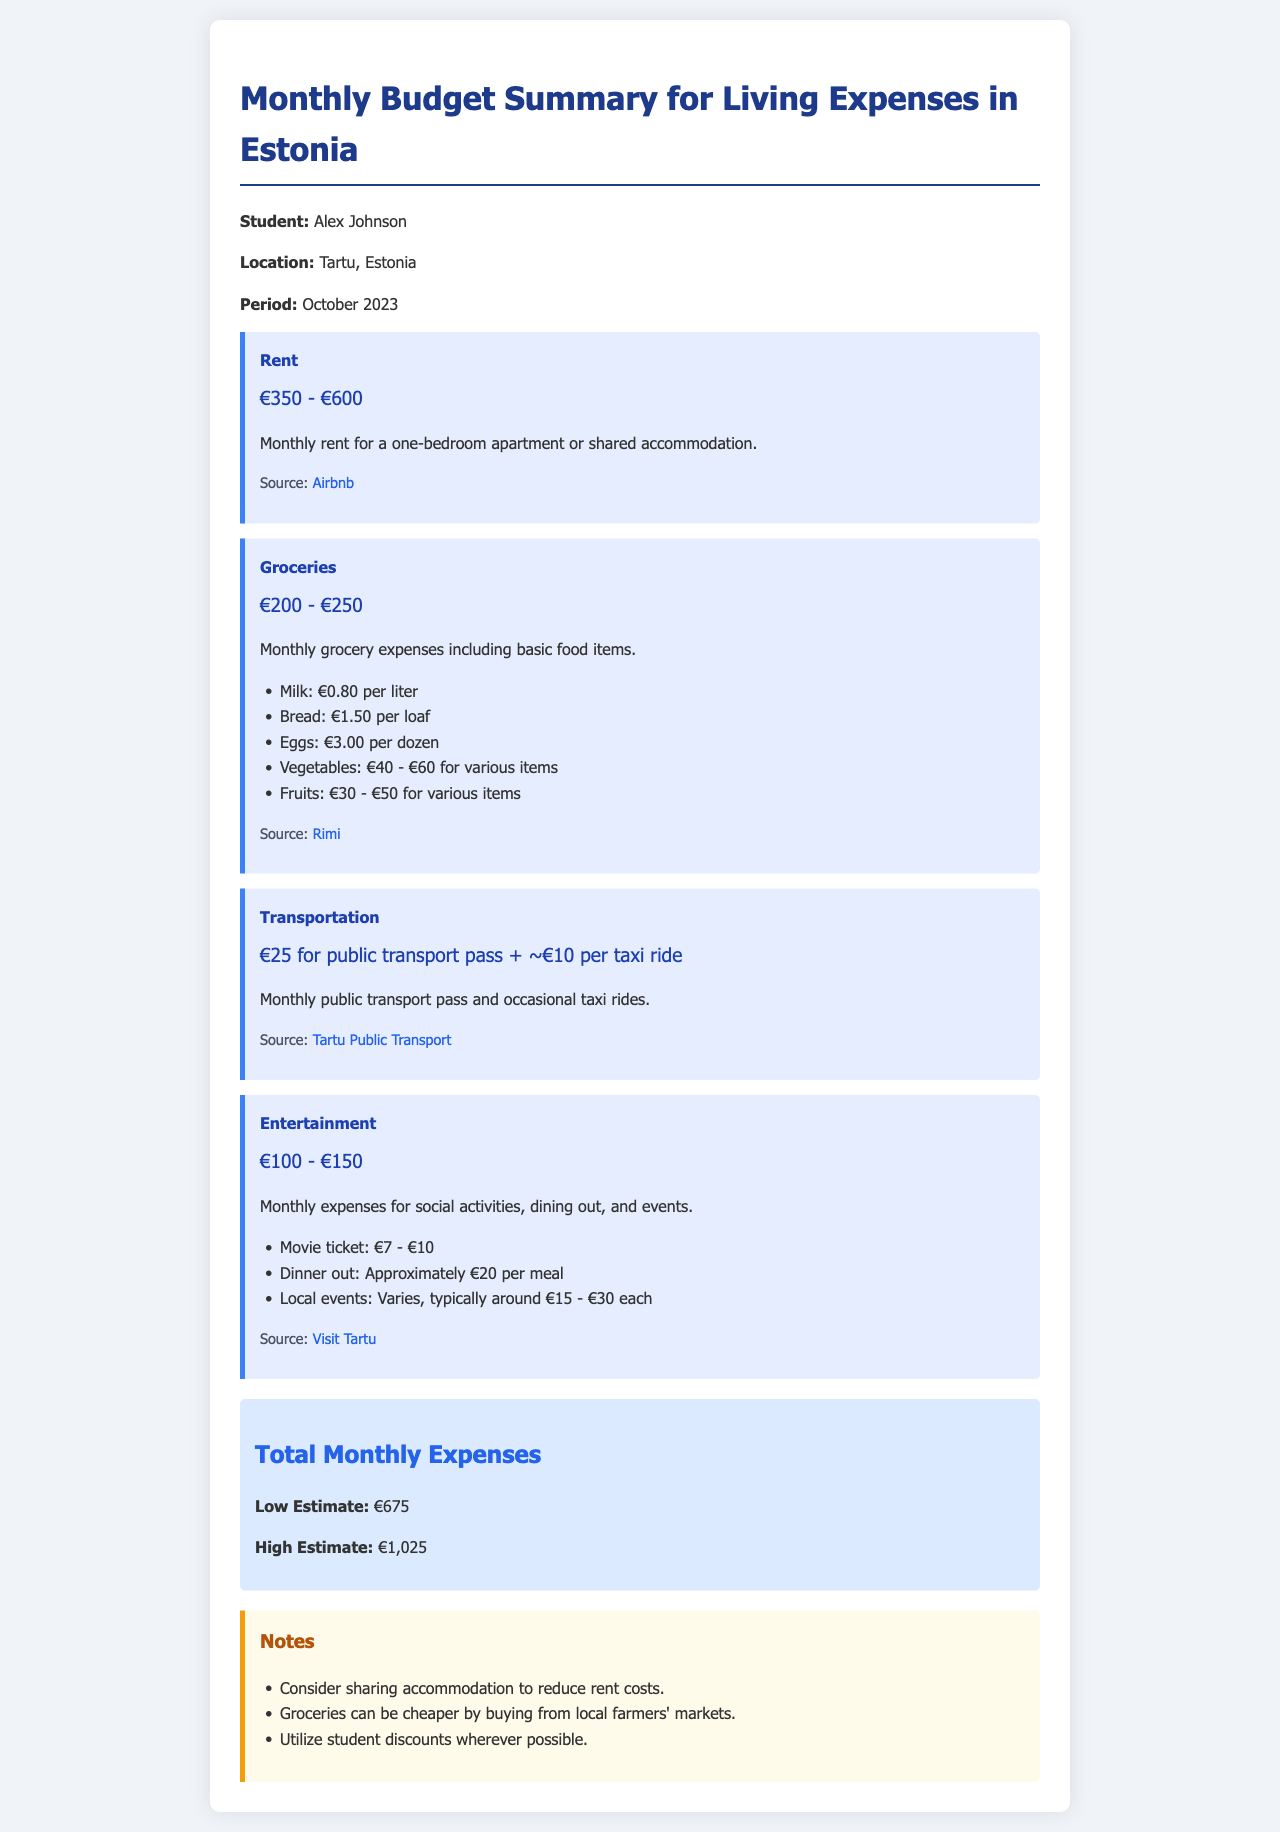What is the student’s name? The document specifies the student's name as Alex Johnson.
Answer: Alex Johnson What is the location mentioned in the document? The location specified for the expenses is Tartu, Estonia.
Answer: Tartu, Estonia What is the range of monthly rent? The document states the monthly rent ranges from €350 to €600 for accommodation.
Answer: €350 - €600 How much is the low estimate for total monthly expenses? The low estimate for total monthly expenses is provided in the document as €675.
Answer: €675 What should students consider to reduce rent costs? The document suggests considering sharing accommodation to lower rent expenses.
Answer: Sharing accommodation What is the average cost for a movie ticket? The average cost for a movie ticket is mentioned as ranging from €7 to €10.
Answer: €7 - €10 What is the estimated monthly cost for groceries? The document specifies the monthly grocery expenses to be between €200 and €250.
Answer: €200 - €250 What is the source for rent information? The source specified for rent information is Airbnb.
Answer: Airbnb What can students do to make groceries cheaper? The document recommends buying from local farmers' markets for cheaper groceries.
Answer: Local farmers' markets 